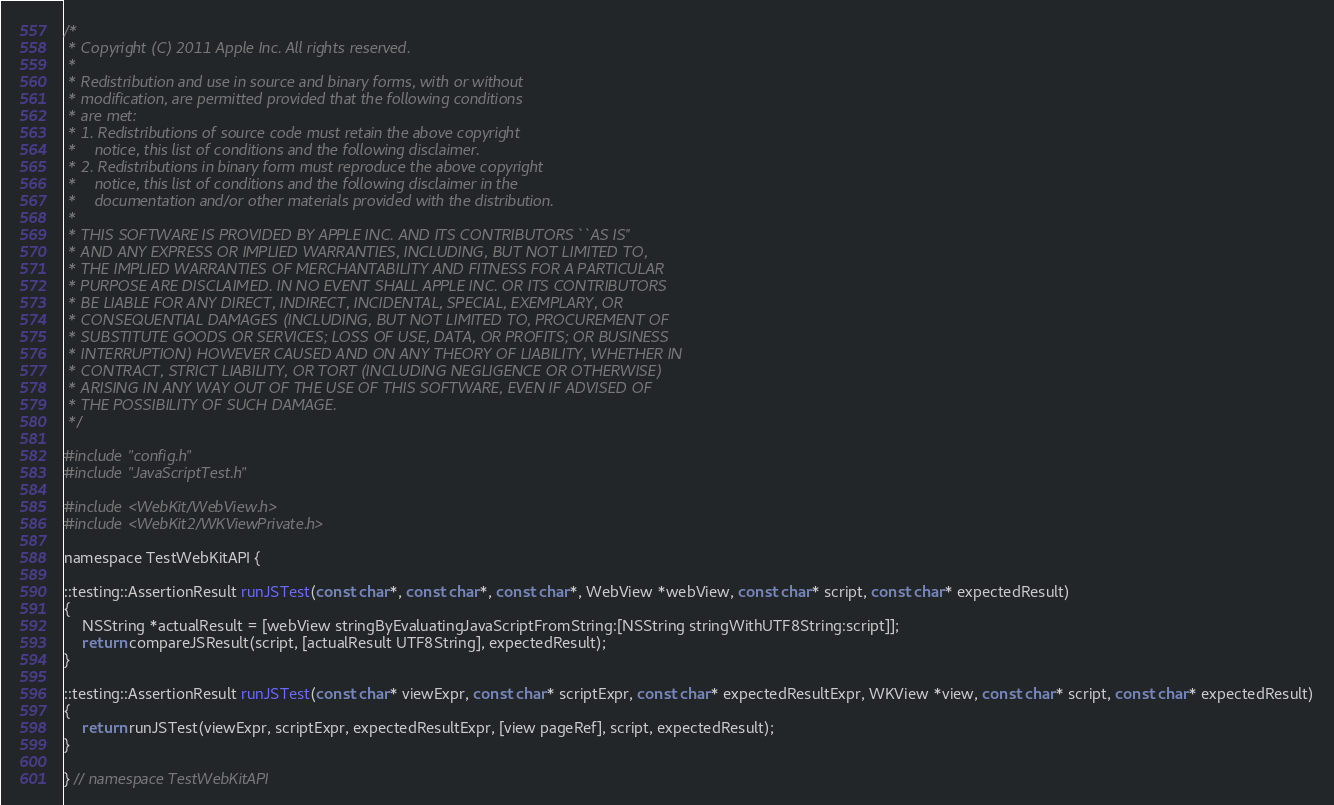<code> <loc_0><loc_0><loc_500><loc_500><_ObjectiveC_>/*
 * Copyright (C) 2011 Apple Inc. All rights reserved.
 *
 * Redistribution and use in source and binary forms, with or without
 * modification, are permitted provided that the following conditions
 * are met:
 * 1. Redistributions of source code must retain the above copyright
 *    notice, this list of conditions and the following disclaimer.
 * 2. Redistributions in binary form must reproduce the above copyright
 *    notice, this list of conditions and the following disclaimer in the
 *    documentation and/or other materials provided with the distribution.
 *
 * THIS SOFTWARE IS PROVIDED BY APPLE INC. AND ITS CONTRIBUTORS ``AS IS''
 * AND ANY EXPRESS OR IMPLIED WARRANTIES, INCLUDING, BUT NOT LIMITED TO,
 * THE IMPLIED WARRANTIES OF MERCHANTABILITY AND FITNESS FOR A PARTICULAR
 * PURPOSE ARE DISCLAIMED. IN NO EVENT SHALL APPLE INC. OR ITS CONTRIBUTORS
 * BE LIABLE FOR ANY DIRECT, INDIRECT, INCIDENTAL, SPECIAL, EXEMPLARY, OR
 * CONSEQUENTIAL DAMAGES (INCLUDING, BUT NOT LIMITED TO, PROCUREMENT OF
 * SUBSTITUTE GOODS OR SERVICES; LOSS OF USE, DATA, OR PROFITS; OR BUSINESS
 * INTERRUPTION) HOWEVER CAUSED AND ON ANY THEORY OF LIABILITY, WHETHER IN
 * CONTRACT, STRICT LIABILITY, OR TORT (INCLUDING NEGLIGENCE OR OTHERWISE)
 * ARISING IN ANY WAY OUT OF THE USE OF THIS SOFTWARE, EVEN IF ADVISED OF
 * THE POSSIBILITY OF SUCH DAMAGE.
 */

#include "config.h"
#include "JavaScriptTest.h"

#include <WebKit/WebView.h>
#include <WebKit2/WKViewPrivate.h>

namespace TestWebKitAPI {

::testing::AssertionResult runJSTest(const char*, const char*, const char*, WebView *webView, const char* script, const char* expectedResult)
{
    NSString *actualResult = [webView stringByEvaluatingJavaScriptFromString:[NSString stringWithUTF8String:script]];
    return compareJSResult(script, [actualResult UTF8String], expectedResult);
}

::testing::AssertionResult runJSTest(const char* viewExpr, const char* scriptExpr, const char* expectedResultExpr, WKView *view, const char* script, const char* expectedResult)
{
    return runJSTest(viewExpr, scriptExpr, expectedResultExpr, [view pageRef], script, expectedResult);
}

} // namespace TestWebKitAPI
</code> 